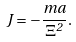<formula> <loc_0><loc_0><loc_500><loc_500>J = - \frac { m a } { \Xi ^ { 2 } } .</formula> 